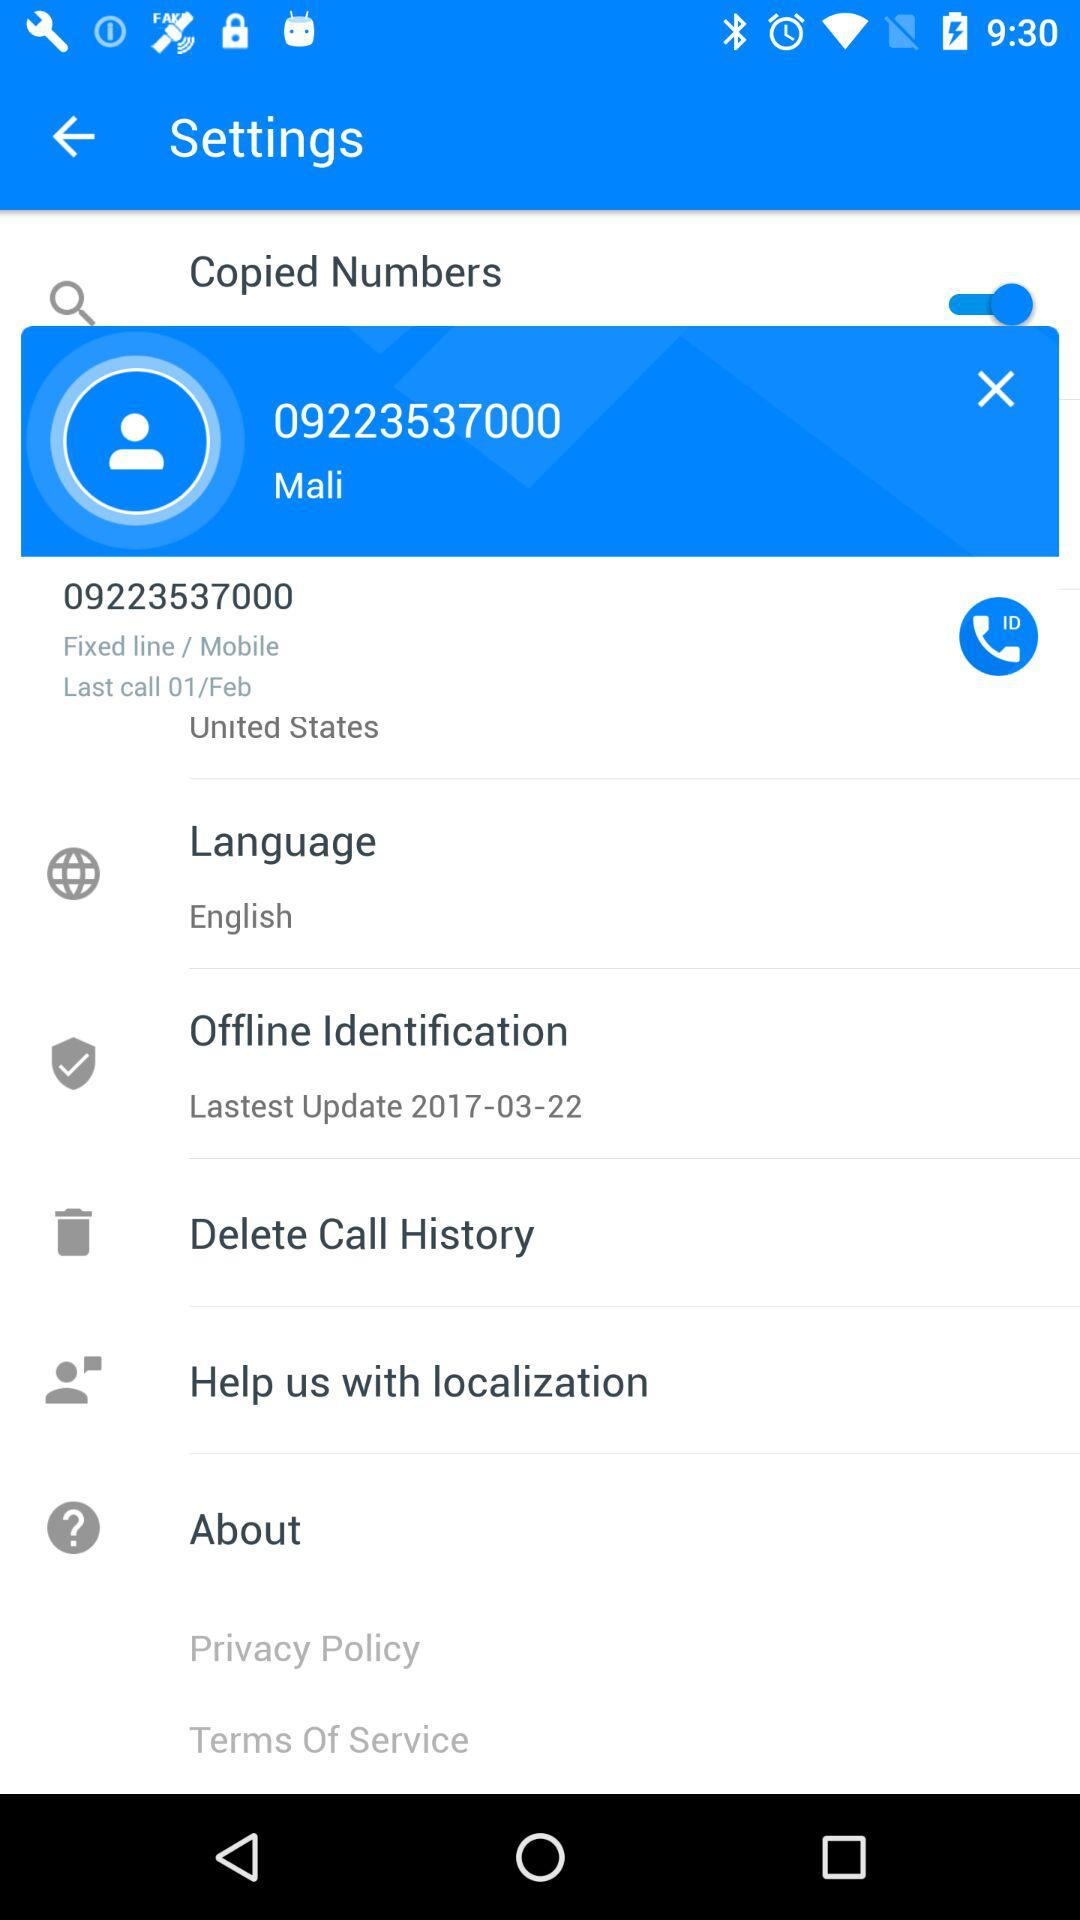Has the user agreed to the terms of service and privacy policy?
When the provided information is insufficient, respond with <no answer>. <no answer> 